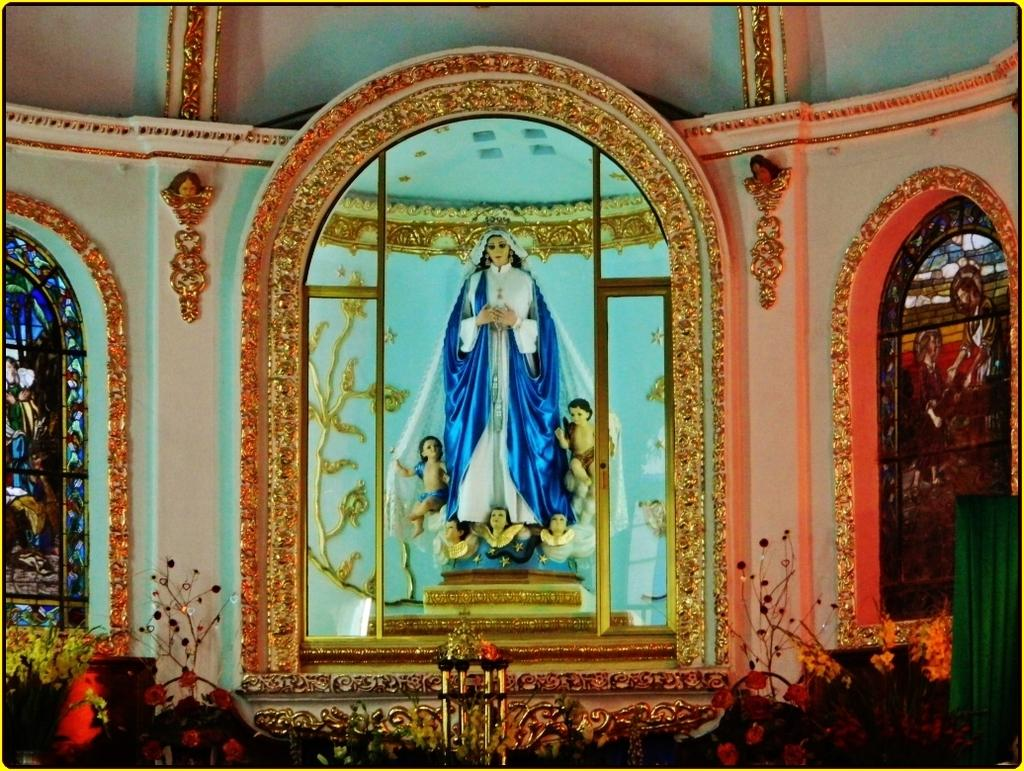What type of building is shown in the image? The image depicts the inside view of a church. Are there any specific features or objects in the church? Yes, there is a statue in the church. What can be seen on the sides of the image? There are there any windows? What type of wool is being used to create the army uniforms in the image? There is no army or wool present in the image; it features the inside view of a church with a statue and stained glass windows. 